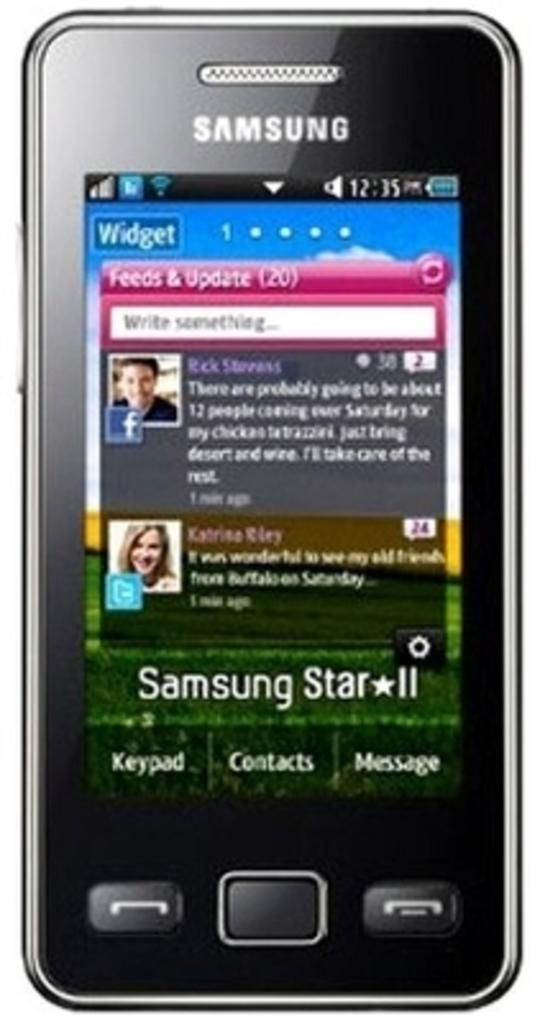<image>
Describe the image concisely. a close up of a Samsung Star II phone with a Widget page showing 